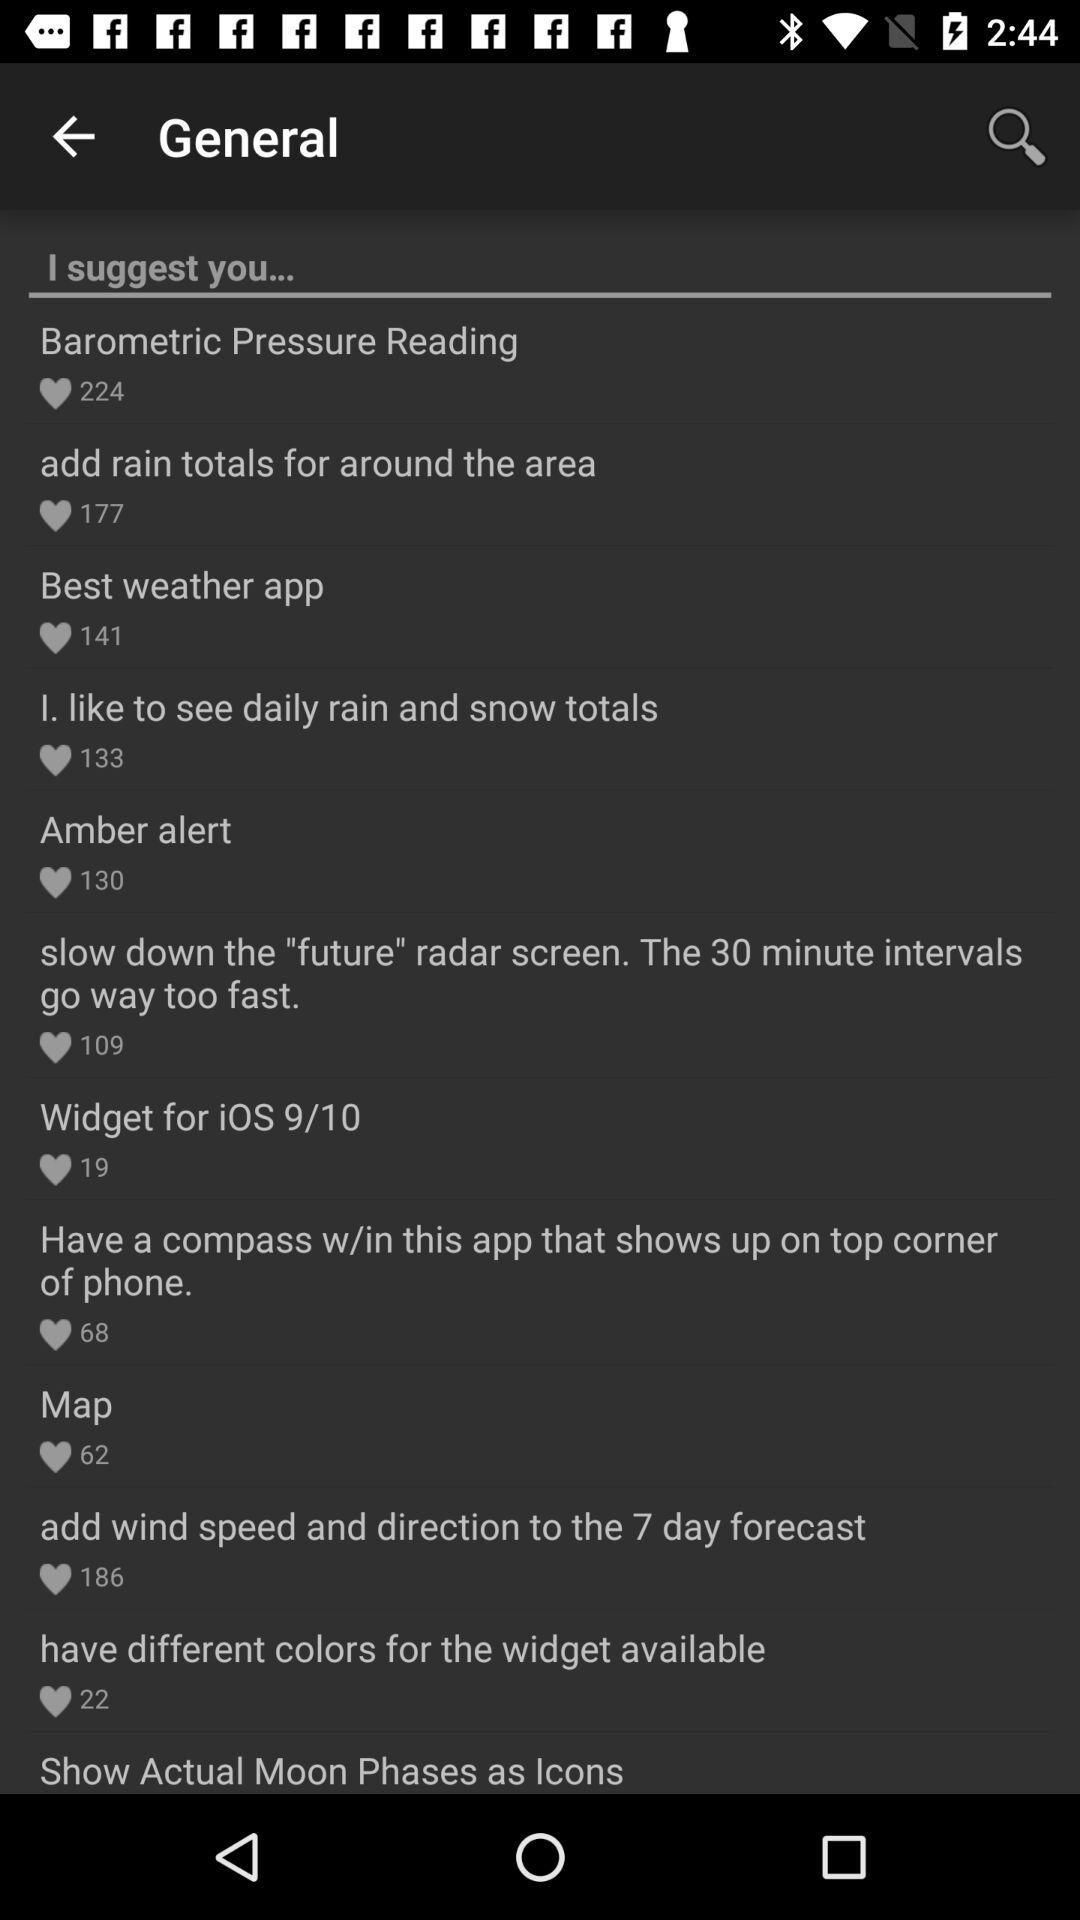How many people like "Amber alert"? "Amber alert" is liked by 130 people. 